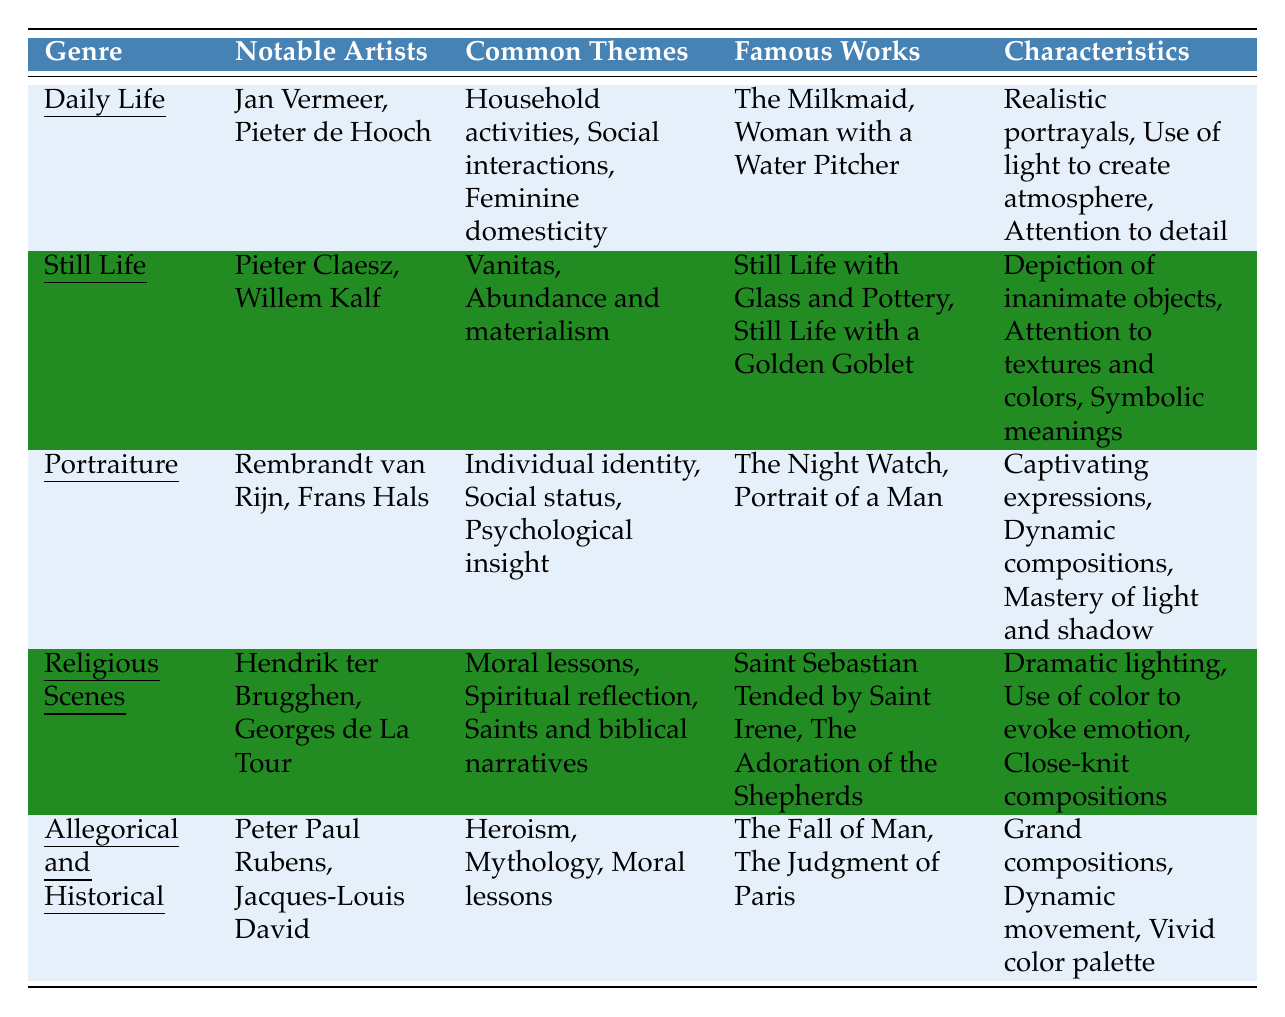What genre is associated with Jan Vermeer and Pieter de Hooch? The table lists "Daily Life" as the genre alongside the notable artists Jan Vermeer and Pieter de Hooch.
Answer: Daily Life Which two artists are known for Still Life paintings? The table indicates that Pieter Claesz and Willem Kalf are the notable artists in the Still Life genre.
Answer: Pieter Claesz and Willem Kalf What are the common themes in Portraiture genre? According to the table, the common themes listed under Portraiture are individual identity, social status, and psychological insight.
Answer: Individual identity, social status, psychological insight True or False: "The Night Watch" is a famous work in the Still Life genre. The table specifies "The Night Watch" under the Portraiture genre and does not list it under Still Life, making the statement false.
Answer: False Which genre has a focus on moral lessons and spiritual reflection? The table shows that Religious Scenes primarily deals with moral lessons and spiritual reflection in its common themes.
Answer: Religious Scenes Name a notable artist associated with Allegorical and Historical genre. The table lists Peter Paul Rubens and Jacques-Louis David as notable artists in the Allegorical and Historical genre.
Answer: Peter Paul Rubens and Jacques-Louis David How many common themes are listed for Daily Life? The table shows three common themes for Daily Life: household activities, social interactions, and feminine domesticity, which indicates the total is three.
Answer: 3 Which genre focuses on the depiction of inanimate objects? The table shows that the genre dedicated to inanimate objects is Still Life, giving it a focus on such depictions.
Answer: Still Life What is the relationship between the genre and famous works in Allegorical and Historical? The table connects Allegorical and Historical with famous works "The Fall of Man" and "The Judgment of Paris," showing that both works exemplify this genre.
Answer: The Fall of Man, The Judgment of Paris What is one characteristic that describes both Portraiture and Religious Scenes? The table states Portraiture and Religious Scenes both include the use of light and color to create specific effects: mastery in Portraiture and dramatic lighting in Religious Scenes.
Answer: Use of light and color 